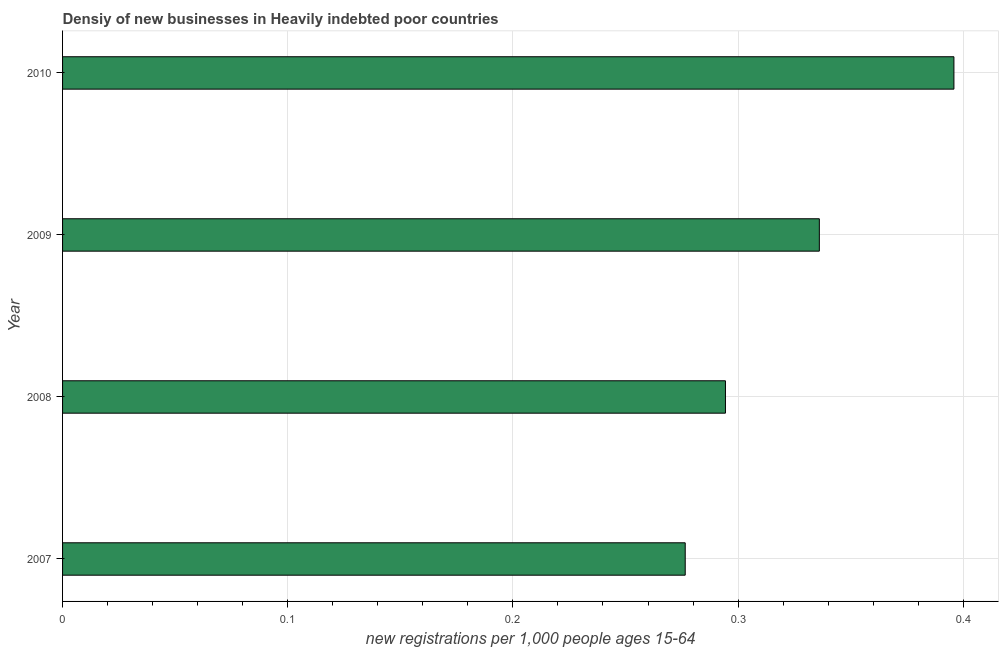Does the graph contain any zero values?
Make the answer very short. No. Does the graph contain grids?
Make the answer very short. Yes. What is the title of the graph?
Offer a very short reply. Densiy of new businesses in Heavily indebted poor countries. What is the label or title of the X-axis?
Your answer should be compact. New registrations per 1,0 people ages 15-64. What is the density of new business in 2007?
Your answer should be compact. 0.28. Across all years, what is the maximum density of new business?
Make the answer very short. 0.4. Across all years, what is the minimum density of new business?
Provide a short and direct response. 0.28. In which year was the density of new business maximum?
Your answer should be compact. 2010. What is the sum of the density of new business?
Offer a terse response. 1.3. What is the difference between the density of new business in 2008 and 2009?
Your answer should be very brief. -0.04. What is the average density of new business per year?
Offer a terse response. 0.33. What is the median density of new business?
Your response must be concise. 0.32. In how many years, is the density of new business greater than 0.38 ?
Your answer should be very brief. 1. What is the ratio of the density of new business in 2007 to that in 2008?
Ensure brevity in your answer.  0.94. Is the density of new business in 2007 less than that in 2008?
Offer a very short reply. Yes. What is the difference between the highest and the second highest density of new business?
Offer a very short reply. 0.06. What is the difference between the highest and the lowest density of new business?
Provide a short and direct response. 0.12. In how many years, is the density of new business greater than the average density of new business taken over all years?
Make the answer very short. 2. Are all the bars in the graph horizontal?
Your response must be concise. Yes. What is the difference between two consecutive major ticks on the X-axis?
Give a very brief answer. 0.1. Are the values on the major ticks of X-axis written in scientific E-notation?
Provide a short and direct response. No. What is the new registrations per 1,000 people ages 15-64 in 2007?
Provide a succinct answer. 0.28. What is the new registrations per 1,000 people ages 15-64 of 2008?
Your response must be concise. 0.29. What is the new registrations per 1,000 people ages 15-64 in 2009?
Your answer should be very brief. 0.34. What is the new registrations per 1,000 people ages 15-64 in 2010?
Provide a short and direct response. 0.4. What is the difference between the new registrations per 1,000 people ages 15-64 in 2007 and 2008?
Your answer should be very brief. -0.02. What is the difference between the new registrations per 1,000 people ages 15-64 in 2007 and 2009?
Ensure brevity in your answer.  -0.06. What is the difference between the new registrations per 1,000 people ages 15-64 in 2007 and 2010?
Provide a short and direct response. -0.12. What is the difference between the new registrations per 1,000 people ages 15-64 in 2008 and 2009?
Your answer should be very brief. -0.04. What is the difference between the new registrations per 1,000 people ages 15-64 in 2008 and 2010?
Offer a terse response. -0.1. What is the difference between the new registrations per 1,000 people ages 15-64 in 2009 and 2010?
Your answer should be compact. -0.06. What is the ratio of the new registrations per 1,000 people ages 15-64 in 2007 to that in 2008?
Provide a succinct answer. 0.94. What is the ratio of the new registrations per 1,000 people ages 15-64 in 2007 to that in 2009?
Give a very brief answer. 0.82. What is the ratio of the new registrations per 1,000 people ages 15-64 in 2007 to that in 2010?
Make the answer very short. 0.7. What is the ratio of the new registrations per 1,000 people ages 15-64 in 2008 to that in 2009?
Ensure brevity in your answer.  0.88. What is the ratio of the new registrations per 1,000 people ages 15-64 in 2008 to that in 2010?
Offer a terse response. 0.74. What is the ratio of the new registrations per 1,000 people ages 15-64 in 2009 to that in 2010?
Provide a short and direct response. 0.85. 